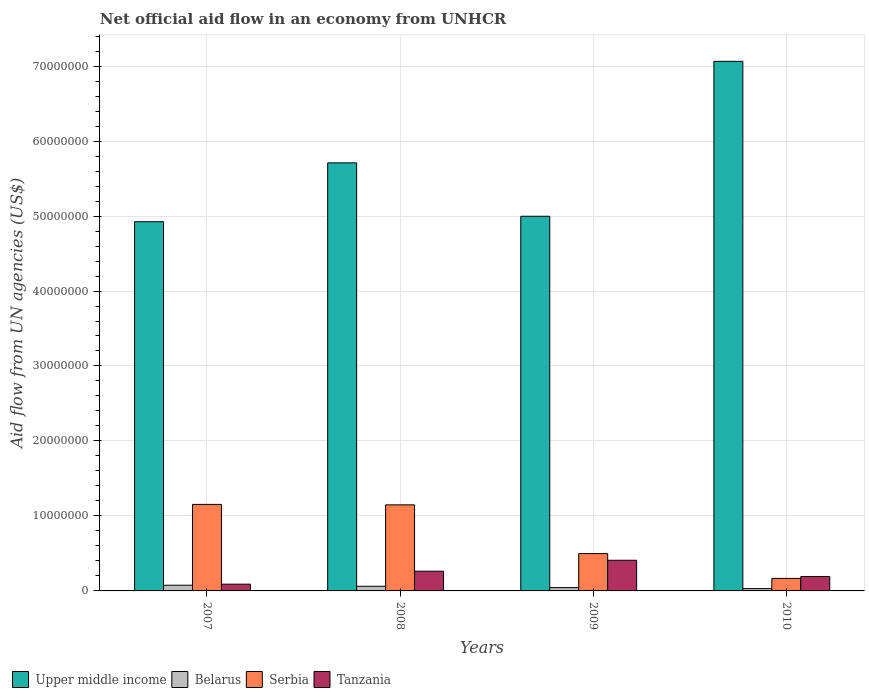Are the number of bars on each tick of the X-axis equal?
Your answer should be very brief. Yes. In how many cases, is the number of bars for a given year not equal to the number of legend labels?
Offer a terse response. 0. What is the net official aid flow in Upper middle income in 2009?
Ensure brevity in your answer.  5.00e+07. Across all years, what is the maximum net official aid flow in Upper middle income?
Offer a very short reply. 7.06e+07. In which year was the net official aid flow in Belarus minimum?
Ensure brevity in your answer.  2010. What is the total net official aid flow in Upper middle income in the graph?
Make the answer very short. 2.27e+08. What is the difference between the net official aid flow in Upper middle income in 2007 and that in 2008?
Offer a very short reply. -7.85e+06. What is the difference between the net official aid flow in Upper middle income in 2007 and the net official aid flow in Tanzania in 2008?
Provide a succinct answer. 4.66e+07. What is the average net official aid flow in Upper middle income per year?
Offer a very short reply. 5.67e+07. What is the ratio of the net official aid flow in Serbia in 2007 to that in 2008?
Make the answer very short. 1.01. Is the net official aid flow in Upper middle income in 2007 less than that in 2009?
Provide a short and direct response. Yes. Is the difference between the net official aid flow in Serbia in 2008 and 2010 greater than the difference between the net official aid flow in Tanzania in 2008 and 2010?
Offer a very short reply. Yes. What is the difference between the highest and the second highest net official aid flow in Belarus?
Your answer should be compact. 1.40e+05. What is the difference between the highest and the lowest net official aid flow in Tanzania?
Keep it short and to the point. 3.19e+06. Is the sum of the net official aid flow in Tanzania in 2007 and 2008 greater than the maximum net official aid flow in Serbia across all years?
Provide a short and direct response. No. Is it the case that in every year, the sum of the net official aid flow in Tanzania and net official aid flow in Belarus is greater than the sum of net official aid flow in Serbia and net official aid flow in Upper middle income?
Make the answer very short. No. What does the 4th bar from the left in 2009 represents?
Give a very brief answer. Tanzania. What does the 2nd bar from the right in 2009 represents?
Keep it short and to the point. Serbia. Is it the case that in every year, the sum of the net official aid flow in Serbia and net official aid flow in Tanzania is greater than the net official aid flow in Upper middle income?
Your answer should be very brief. No. How many bars are there?
Make the answer very short. 16. What is the difference between two consecutive major ticks on the Y-axis?
Your answer should be compact. 1.00e+07. Does the graph contain any zero values?
Provide a succinct answer. No. Where does the legend appear in the graph?
Make the answer very short. Bottom left. How many legend labels are there?
Your answer should be very brief. 4. How are the legend labels stacked?
Keep it short and to the point. Horizontal. What is the title of the graph?
Ensure brevity in your answer.  Net official aid flow in an economy from UNHCR. What is the label or title of the Y-axis?
Your answer should be compact. Aid flow from UN agencies (US$). What is the Aid flow from UN agencies (US$) in Upper middle income in 2007?
Provide a succinct answer. 4.92e+07. What is the Aid flow from UN agencies (US$) in Belarus in 2007?
Make the answer very short. 7.60e+05. What is the Aid flow from UN agencies (US$) of Serbia in 2007?
Keep it short and to the point. 1.15e+07. What is the Aid flow from UN agencies (US$) in Tanzania in 2007?
Your answer should be very brief. 9.00e+05. What is the Aid flow from UN agencies (US$) in Upper middle income in 2008?
Provide a short and direct response. 5.71e+07. What is the Aid flow from UN agencies (US$) in Belarus in 2008?
Keep it short and to the point. 6.20e+05. What is the Aid flow from UN agencies (US$) of Serbia in 2008?
Make the answer very short. 1.15e+07. What is the Aid flow from UN agencies (US$) in Tanzania in 2008?
Your response must be concise. 2.63e+06. What is the Aid flow from UN agencies (US$) in Upper middle income in 2009?
Provide a short and direct response. 5.00e+07. What is the Aid flow from UN agencies (US$) in Belarus in 2009?
Provide a succinct answer. 4.40e+05. What is the Aid flow from UN agencies (US$) in Serbia in 2009?
Ensure brevity in your answer.  4.98e+06. What is the Aid flow from UN agencies (US$) of Tanzania in 2009?
Ensure brevity in your answer.  4.09e+06. What is the Aid flow from UN agencies (US$) of Upper middle income in 2010?
Make the answer very short. 7.06e+07. What is the Aid flow from UN agencies (US$) in Serbia in 2010?
Ensure brevity in your answer.  1.67e+06. What is the Aid flow from UN agencies (US$) in Tanzania in 2010?
Your answer should be very brief. 1.92e+06. Across all years, what is the maximum Aid flow from UN agencies (US$) of Upper middle income?
Provide a succinct answer. 7.06e+07. Across all years, what is the maximum Aid flow from UN agencies (US$) of Belarus?
Give a very brief answer. 7.60e+05. Across all years, what is the maximum Aid flow from UN agencies (US$) in Serbia?
Your response must be concise. 1.15e+07. Across all years, what is the maximum Aid flow from UN agencies (US$) of Tanzania?
Keep it short and to the point. 4.09e+06. Across all years, what is the minimum Aid flow from UN agencies (US$) of Upper middle income?
Provide a short and direct response. 4.92e+07. Across all years, what is the minimum Aid flow from UN agencies (US$) of Serbia?
Keep it short and to the point. 1.67e+06. What is the total Aid flow from UN agencies (US$) in Upper middle income in the graph?
Keep it short and to the point. 2.27e+08. What is the total Aid flow from UN agencies (US$) of Belarus in the graph?
Make the answer very short. 2.13e+06. What is the total Aid flow from UN agencies (US$) in Serbia in the graph?
Make the answer very short. 2.97e+07. What is the total Aid flow from UN agencies (US$) of Tanzania in the graph?
Offer a very short reply. 9.54e+06. What is the difference between the Aid flow from UN agencies (US$) in Upper middle income in 2007 and that in 2008?
Give a very brief answer. -7.85e+06. What is the difference between the Aid flow from UN agencies (US$) of Belarus in 2007 and that in 2008?
Make the answer very short. 1.40e+05. What is the difference between the Aid flow from UN agencies (US$) in Tanzania in 2007 and that in 2008?
Keep it short and to the point. -1.73e+06. What is the difference between the Aid flow from UN agencies (US$) of Upper middle income in 2007 and that in 2009?
Provide a short and direct response. -7.30e+05. What is the difference between the Aid flow from UN agencies (US$) in Serbia in 2007 and that in 2009?
Keep it short and to the point. 6.56e+06. What is the difference between the Aid flow from UN agencies (US$) of Tanzania in 2007 and that in 2009?
Provide a succinct answer. -3.19e+06. What is the difference between the Aid flow from UN agencies (US$) in Upper middle income in 2007 and that in 2010?
Your answer should be very brief. -2.14e+07. What is the difference between the Aid flow from UN agencies (US$) of Belarus in 2007 and that in 2010?
Give a very brief answer. 4.50e+05. What is the difference between the Aid flow from UN agencies (US$) of Serbia in 2007 and that in 2010?
Keep it short and to the point. 9.87e+06. What is the difference between the Aid flow from UN agencies (US$) of Tanzania in 2007 and that in 2010?
Keep it short and to the point. -1.02e+06. What is the difference between the Aid flow from UN agencies (US$) of Upper middle income in 2008 and that in 2009?
Provide a short and direct response. 7.12e+06. What is the difference between the Aid flow from UN agencies (US$) of Serbia in 2008 and that in 2009?
Your answer should be compact. 6.50e+06. What is the difference between the Aid flow from UN agencies (US$) in Tanzania in 2008 and that in 2009?
Ensure brevity in your answer.  -1.46e+06. What is the difference between the Aid flow from UN agencies (US$) of Upper middle income in 2008 and that in 2010?
Your response must be concise. -1.35e+07. What is the difference between the Aid flow from UN agencies (US$) in Belarus in 2008 and that in 2010?
Make the answer very short. 3.10e+05. What is the difference between the Aid flow from UN agencies (US$) of Serbia in 2008 and that in 2010?
Provide a short and direct response. 9.81e+06. What is the difference between the Aid flow from UN agencies (US$) in Tanzania in 2008 and that in 2010?
Provide a succinct answer. 7.10e+05. What is the difference between the Aid flow from UN agencies (US$) of Upper middle income in 2009 and that in 2010?
Your answer should be compact. -2.07e+07. What is the difference between the Aid flow from UN agencies (US$) of Belarus in 2009 and that in 2010?
Your response must be concise. 1.30e+05. What is the difference between the Aid flow from UN agencies (US$) of Serbia in 2009 and that in 2010?
Your answer should be very brief. 3.31e+06. What is the difference between the Aid flow from UN agencies (US$) of Tanzania in 2009 and that in 2010?
Ensure brevity in your answer.  2.17e+06. What is the difference between the Aid flow from UN agencies (US$) of Upper middle income in 2007 and the Aid flow from UN agencies (US$) of Belarus in 2008?
Ensure brevity in your answer.  4.86e+07. What is the difference between the Aid flow from UN agencies (US$) in Upper middle income in 2007 and the Aid flow from UN agencies (US$) in Serbia in 2008?
Your answer should be very brief. 3.78e+07. What is the difference between the Aid flow from UN agencies (US$) of Upper middle income in 2007 and the Aid flow from UN agencies (US$) of Tanzania in 2008?
Your answer should be very brief. 4.66e+07. What is the difference between the Aid flow from UN agencies (US$) of Belarus in 2007 and the Aid flow from UN agencies (US$) of Serbia in 2008?
Offer a very short reply. -1.07e+07. What is the difference between the Aid flow from UN agencies (US$) in Belarus in 2007 and the Aid flow from UN agencies (US$) in Tanzania in 2008?
Keep it short and to the point. -1.87e+06. What is the difference between the Aid flow from UN agencies (US$) of Serbia in 2007 and the Aid flow from UN agencies (US$) of Tanzania in 2008?
Make the answer very short. 8.91e+06. What is the difference between the Aid flow from UN agencies (US$) in Upper middle income in 2007 and the Aid flow from UN agencies (US$) in Belarus in 2009?
Make the answer very short. 4.88e+07. What is the difference between the Aid flow from UN agencies (US$) in Upper middle income in 2007 and the Aid flow from UN agencies (US$) in Serbia in 2009?
Provide a short and direct response. 4.43e+07. What is the difference between the Aid flow from UN agencies (US$) of Upper middle income in 2007 and the Aid flow from UN agencies (US$) of Tanzania in 2009?
Your answer should be compact. 4.52e+07. What is the difference between the Aid flow from UN agencies (US$) of Belarus in 2007 and the Aid flow from UN agencies (US$) of Serbia in 2009?
Ensure brevity in your answer.  -4.22e+06. What is the difference between the Aid flow from UN agencies (US$) of Belarus in 2007 and the Aid flow from UN agencies (US$) of Tanzania in 2009?
Provide a short and direct response. -3.33e+06. What is the difference between the Aid flow from UN agencies (US$) in Serbia in 2007 and the Aid flow from UN agencies (US$) in Tanzania in 2009?
Offer a terse response. 7.45e+06. What is the difference between the Aid flow from UN agencies (US$) in Upper middle income in 2007 and the Aid flow from UN agencies (US$) in Belarus in 2010?
Keep it short and to the point. 4.89e+07. What is the difference between the Aid flow from UN agencies (US$) in Upper middle income in 2007 and the Aid flow from UN agencies (US$) in Serbia in 2010?
Ensure brevity in your answer.  4.76e+07. What is the difference between the Aid flow from UN agencies (US$) in Upper middle income in 2007 and the Aid flow from UN agencies (US$) in Tanzania in 2010?
Provide a short and direct response. 4.73e+07. What is the difference between the Aid flow from UN agencies (US$) of Belarus in 2007 and the Aid flow from UN agencies (US$) of Serbia in 2010?
Your response must be concise. -9.10e+05. What is the difference between the Aid flow from UN agencies (US$) in Belarus in 2007 and the Aid flow from UN agencies (US$) in Tanzania in 2010?
Keep it short and to the point. -1.16e+06. What is the difference between the Aid flow from UN agencies (US$) of Serbia in 2007 and the Aid flow from UN agencies (US$) of Tanzania in 2010?
Your answer should be compact. 9.62e+06. What is the difference between the Aid flow from UN agencies (US$) in Upper middle income in 2008 and the Aid flow from UN agencies (US$) in Belarus in 2009?
Keep it short and to the point. 5.66e+07. What is the difference between the Aid flow from UN agencies (US$) of Upper middle income in 2008 and the Aid flow from UN agencies (US$) of Serbia in 2009?
Make the answer very short. 5.21e+07. What is the difference between the Aid flow from UN agencies (US$) in Upper middle income in 2008 and the Aid flow from UN agencies (US$) in Tanzania in 2009?
Provide a succinct answer. 5.30e+07. What is the difference between the Aid flow from UN agencies (US$) of Belarus in 2008 and the Aid flow from UN agencies (US$) of Serbia in 2009?
Your response must be concise. -4.36e+06. What is the difference between the Aid flow from UN agencies (US$) of Belarus in 2008 and the Aid flow from UN agencies (US$) of Tanzania in 2009?
Ensure brevity in your answer.  -3.47e+06. What is the difference between the Aid flow from UN agencies (US$) of Serbia in 2008 and the Aid flow from UN agencies (US$) of Tanzania in 2009?
Offer a very short reply. 7.39e+06. What is the difference between the Aid flow from UN agencies (US$) of Upper middle income in 2008 and the Aid flow from UN agencies (US$) of Belarus in 2010?
Ensure brevity in your answer.  5.68e+07. What is the difference between the Aid flow from UN agencies (US$) of Upper middle income in 2008 and the Aid flow from UN agencies (US$) of Serbia in 2010?
Ensure brevity in your answer.  5.54e+07. What is the difference between the Aid flow from UN agencies (US$) of Upper middle income in 2008 and the Aid flow from UN agencies (US$) of Tanzania in 2010?
Provide a short and direct response. 5.52e+07. What is the difference between the Aid flow from UN agencies (US$) of Belarus in 2008 and the Aid flow from UN agencies (US$) of Serbia in 2010?
Provide a short and direct response. -1.05e+06. What is the difference between the Aid flow from UN agencies (US$) of Belarus in 2008 and the Aid flow from UN agencies (US$) of Tanzania in 2010?
Your answer should be very brief. -1.30e+06. What is the difference between the Aid flow from UN agencies (US$) of Serbia in 2008 and the Aid flow from UN agencies (US$) of Tanzania in 2010?
Make the answer very short. 9.56e+06. What is the difference between the Aid flow from UN agencies (US$) in Upper middle income in 2009 and the Aid flow from UN agencies (US$) in Belarus in 2010?
Keep it short and to the point. 4.97e+07. What is the difference between the Aid flow from UN agencies (US$) in Upper middle income in 2009 and the Aid flow from UN agencies (US$) in Serbia in 2010?
Offer a terse response. 4.83e+07. What is the difference between the Aid flow from UN agencies (US$) in Upper middle income in 2009 and the Aid flow from UN agencies (US$) in Tanzania in 2010?
Provide a succinct answer. 4.80e+07. What is the difference between the Aid flow from UN agencies (US$) of Belarus in 2009 and the Aid flow from UN agencies (US$) of Serbia in 2010?
Make the answer very short. -1.23e+06. What is the difference between the Aid flow from UN agencies (US$) in Belarus in 2009 and the Aid flow from UN agencies (US$) in Tanzania in 2010?
Provide a short and direct response. -1.48e+06. What is the difference between the Aid flow from UN agencies (US$) of Serbia in 2009 and the Aid flow from UN agencies (US$) of Tanzania in 2010?
Offer a very short reply. 3.06e+06. What is the average Aid flow from UN agencies (US$) of Upper middle income per year?
Your response must be concise. 5.67e+07. What is the average Aid flow from UN agencies (US$) in Belarus per year?
Provide a succinct answer. 5.32e+05. What is the average Aid flow from UN agencies (US$) in Serbia per year?
Provide a short and direct response. 7.42e+06. What is the average Aid flow from UN agencies (US$) of Tanzania per year?
Give a very brief answer. 2.38e+06. In the year 2007, what is the difference between the Aid flow from UN agencies (US$) of Upper middle income and Aid flow from UN agencies (US$) of Belarus?
Your answer should be compact. 4.85e+07. In the year 2007, what is the difference between the Aid flow from UN agencies (US$) of Upper middle income and Aid flow from UN agencies (US$) of Serbia?
Make the answer very short. 3.77e+07. In the year 2007, what is the difference between the Aid flow from UN agencies (US$) of Upper middle income and Aid flow from UN agencies (US$) of Tanzania?
Provide a short and direct response. 4.83e+07. In the year 2007, what is the difference between the Aid flow from UN agencies (US$) in Belarus and Aid flow from UN agencies (US$) in Serbia?
Offer a terse response. -1.08e+07. In the year 2007, what is the difference between the Aid flow from UN agencies (US$) in Serbia and Aid flow from UN agencies (US$) in Tanzania?
Your answer should be compact. 1.06e+07. In the year 2008, what is the difference between the Aid flow from UN agencies (US$) in Upper middle income and Aid flow from UN agencies (US$) in Belarus?
Offer a very short reply. 5.65e+07. In the year 2008, what is the difference between the Aid flow from UN agencies (US$) of Upper middle income and Aid flow from UN agencies (US$) of Serbia?
Make the answer very short. 4.56e+07. In the year 2008, what is the difference between the Aid flow from UN agencies (US$) in Upper middle income and Aid flow from UN agencies (US$) in Tanzania?
Keep it short and to the point. 5.45e+07. In the year 2008, what is the difference between the Aid flow from UN agencies (US$) in Belarus and Aid flow from UN agencies (US$) in Serbia?
Ensure brevity in your answer.  -1.09e+07. In the year 2008, what is the difference between the Aid flow from UN agencies (US$) in Belarus and Aid flow from UN agencies (US$) in Tanzania?
Give a very brief answer. -2.01e+06. In the year 2008, what is the difference between the Aid flow from UN agencies (US$) in Serbia and Aid flow from UN agencies (US$) in Tanzania?
Your answer should be very brief. 8.85e+06. In the year 2009, what is the difference between the Aid flow from UN agencies (US$) in Upper middle income and Aid flow from UN agencies (US$) in Belarus?
Provide a short and direct response. 4.95e+07. In the year 2009, what is the difference between the Aid flow from UN agencies (US$) in Upper middle income and Aid flow from UN agencies (US$) in Serbia?
Provide a succinct answer. 4.50e+07. In the year 2009, what is the difference between the Aid flow from UN agencies (US$) of Upper middle income and Aid flow from UN agencies (US$) of Tanzania?
Your response must be concise. 4.59e+07. In the year 2009, what is the difference between the Aid flow from UN agencies (US$) in Belarus and Aid flow from UN agencies (US$) in Serbia?
Provide a short and direct response. -4.54e+06. In the year 2009, what is the difference between the Aid flow from UN agencies (US$) of Belarus and Aid flow from UN agencies (US$) of Tanzania?
Provide a succinct answer. -3.65e+06. In the year 2009, what is the difference between the Aid flow from UN agencies (US$) of Serbia and Aid flow from UN agencies (US$) of Tanzania?
Keep it short and to the point. 8.90e+05. In the year 2010, what is the difference between the Aid flow from UN agencies (US$) of Upper middle income and Aid flow from UN agencies (US$) of Belarus?
Offer a very short reply. 7.03e+07. In the year 2010, what is the difference between the Aid flow from UN agencies (US$) of Upper middle income and Aid flow from UN agencies (US$) of Serbia?
Your answer should be compact. 6.90e+07. In the year 2010, what is the difference between the Aid flow from UN agencies (US$) in Upper middle income and Aid flow from UN agencies (US$) in Tanzania?
Make the answer very short. 6.87e+07. In the year 2010, what is the difference between the Aid flow from UN agencies (US$) in Belarus and Aid flow from UN agencies (US$) in Serbia?
Offer a very short reply. -1.36e+06. In the year 2010, what is the difference between the Aid flow from UN agencies (US$) in Belarus and Aid flow from UN agencies (US$) in Tanzania?
Offer a terse response. -1.61e+06. What is the ratio of the Aid flow from UN agencies (US$) of Upper middle income in 2007 to that in 2008?
Offer a terse response. 0.86. What is the ratio of the Aid flow from UN agencies (US$) of Belarus in 2007 to that in 2008?
Provide a short and direct response. 1.23. What is the ratio of the Aid flow from UN agencies (US$) of Serbia in 2007 to that in 2008?
Your response must be concise. 1.01. What is the ratio of the Aid flow from UN agencies (US$) in Tanzania in 2007 to that in 2008?
Provide a short and direct response. 0.34. What is the ratio of the Aid flow from UN agencies (US$) in Upper middle income in 2007 to that in 2009?
Provide a short and direct response. 0.99. What is the ratio of the Aid flow from UN agencies (US$) in Belarus in 2007 to that in 2009?
Offer a very short reply. 1.73. What is the ratio of the Aid flow from UN agencies (US$) of Serbia in 2007 to that in 2009?
Keep it short and to the point. 2.32. What is the ratio of the Aid flow from UN agencies (US$) of Tanzania in 2007 to that in 2009?
Give a very brief answer. 0.22. What is the ratio of the Aid flow from UN agencies (US$) in Upper middle income in 2007 to that in 2010?
Keep it short and to the point. 0.7. What is the ratio of the Aid flow from UN agencies (US$) in Belarus in 2007 to that in 2010?
Give a very brief answer. 2.45. What is the ratio of the Aid flow from UN agencies (US$) in Serbia in 2007 to that in 2010?
Offer a terse response. 6.91. What is the ratio of the Aid flow from UN agencies (US$) in Tanzania in 2007 to that in 2010?
Your answer should be very brief. 0.47. What is the ratio of the Aid flow from UN agencies (US$) of Upper middle income in 2008 to that in 2009?
Ensure brevity in your answer.  1.14. What is the ratio of the Aid flow from UN agencies (US$) of Belarus in 2008 to that in 2009?
Offer a very short reply. 1.41. What is the ratio of the Aid flow from UN agencies (US$) in Serbia in 2008 to that in 2009?
Your answer should be very brief. 2.31. What is the ratio of the Aid flow from UN agencies (US$) of Tanzania in 2008 to that in 2009?
Provide a short and direct response. 0.64. What is the ratio of the Aid flow from UN agencies (US$) in Upper middle income in 2008 to that in 2010?
Your answer should be very brief. 0.81. What is the ratio of the Aid flow from UN agencies (US$) in Serbia in 2008 to that in 2010?
Give a very brief answer. 6.87. What is the ratio of the Aid flow from UN agencies (US$) of Tanzania in 2008 to that in 2010?
Offer a terse response. 1.37. What is the ratio of the Aid flow from UN agencies (US$) of Upper middle income in 2009 to that in 2010?
Ensure brevity in your answer.  0.71. What is the ratio of the Aid flow from UN agencies (US$) in Belarus in 2009 to that in 2010?
Offer a very short reply. 1.42. What is the ratio of the Aid flow from UN agencies (US$) of Serbia in 2009 to that in 2010?
Offer a very short reply. 2.98. What is the ratio of the Aid flow from UN agencies (US$) in Tanzania in 2009 to that in 2010?
Ensure brevity in your answer.  2.13. What is the difference between the highest and the second highest Aid flow from UN agencies (US$) of Upper middle income?
Your answer should be compact. 1.35e+07. What is the difference between the highest and the second highest Aid flow from UN agencies (US$) in Serbia?
Provide a short and direct response. 6.00e+04. What is the difference between the highest and the second highest Aid flow from UN agencies (US$) in Tanzania?
Make the answer very short. 1.46e+06. What is the difference between the highest and the lowest Aid flow from UN agencies (US$) of Upper middle income?
Your answer should be very brief. 2.14e+07. What is the difference between the highest and the lowest Aid flow from UN agencies (US$) of Belarus?
Offer a very short reply. 4.50e+05. What is the difference between the highest and the lowest Aid flow from UN agencies (US$) of Serbia?
Keep it short and to the point. 9.87e+06. What is the difference between the highest and the lowest Aid flow from UN agencies (US$) of Tanzania?
Offer a very short reply. 3.19e+06. 